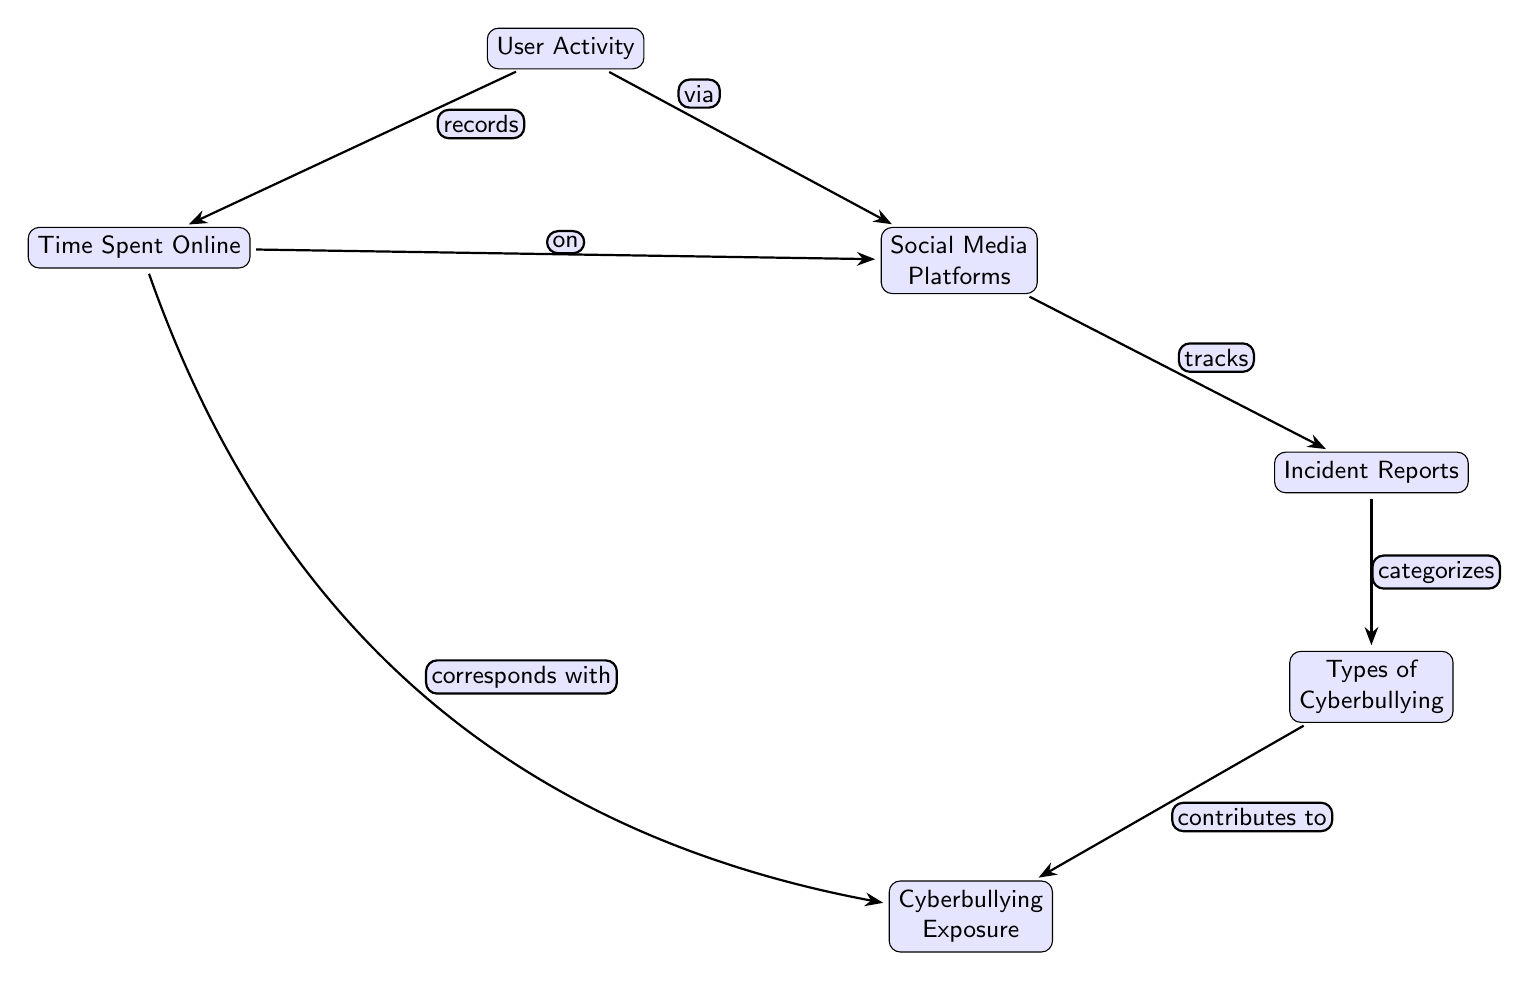What are the two main components connected to User Activity? The diagram shows two main components connected to User Activity: Time Spent Online and Social Media Platforms. This can be directly inferred from the edges leading from the User Activity node.
Answer: Time Spent Online, Social Media Platforms How many nodes are in the diagram? By counting each unique element within the diagram, we find a total of 7 nodes: User Activity, Time Spent Online, Social Media Platforms, Incident Reports, Types of Cyberbullying, Cyberbullying Exposure.
Answer: 6 What type of relationship does Time Spent Online have with Cyberbullying Exposure? The relationship between Time Spent Online and Cyberbullying Exposure is described as "corresponds with" in the diagram, which indicates a direct connection between the two nodes.
Answer: corresponds with What is the flow of information from Incident Reports to Types of Cyberbullying? The flow of information from Incident Reports to Types of Cyberbullying is described as "categorizes." This means the Incident Reports categorize the types of cyberbullying that occur, which can be traced along the connecting edge in the diagram.
Answer: categorizes Which node does Social Media Platforms primarily connect to besides User Activity? Apart from its connection to User Activity, Social Media Platforms primarily connect to Incident Reports, as evidenced by the labeled edge leading from Social Media Platforms to Incident Reports in the diagram.
Answer: Incident Reports What does the edge labeled "tracks" represent in the context between Social Media Platforms and Incident Reports? The edge labeled "tracks" signifies the monitoring or recording function that Social Media Platforms have regarding the Incident Reports, indicating that these platforms are responsible for tracking incidents of cyberbullying.
Answer: tracks 